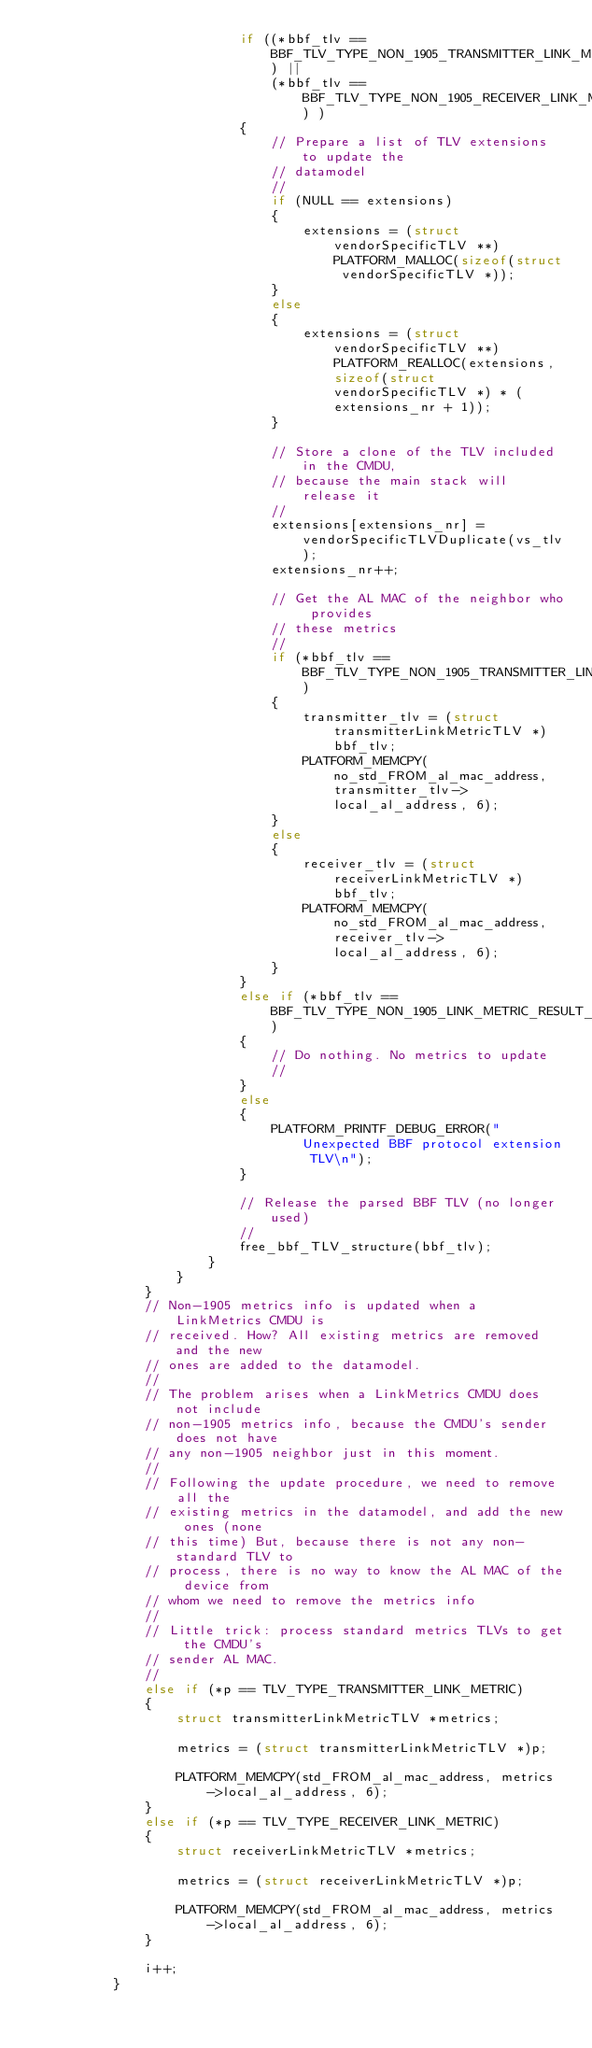<code> <loc_0><loc_0><loc_500><loc_500><_C_>                          if ((*bbf_tlv == BBF_TLV_TYPE_NON_1905_TRANSMITTER_LINK_METRIC) ||
                              (*bbf_tlv == BBF_TLV_TYPE_NON_1905_RECEIVER_LINK_METRIC) )
                          {
                              // Prepare a list of TLV extensions to update the
                              // datamodel
                              //
                              if (NULL == extensions)
                              {
                                  extensions = (struct vendorSpecificTLV **)PLATFORM_MALLOC(sizeof(struct vendorSpecificTLV *));
                              }
                              else
                              {
                                  extensions = (struct vendorSpecificTLV **)PLATFORM_REALLOC(extensions, sizeof(struct vendorSpecificTLV *) * (extensions_nr + 1));
                              }

                              // Store a clone of the TLV included in the CMDU,
                              // because the main stack will release it
                              //
                              extensions[extensions_nr] = vendorSpecificTLVDuplicate(vs_tlv);
                              extensions_nr++;

                              // Get the AL MAC of the neighbor who provides
                              // these metrics
                              //
                              if (*bbf_tlv == BBF_TLV_TYPE_NON_1905_TRANSMITTER_LINK_METRIC)
                              {
                                  transmitter_tlv = (struct transmitterLinkMetricTLV *)bbf_tlv;
                                  PLATFORM_MEMCPY(no_std_FROM_al_mac_address, transmitter_tlv->local_al_address, 6);
                              }
                              else
                              {
                                  receiver_tlv = (struct receiverLinkMetricTLV *)bbf_tlv;
                                  PLATFORM_MEMCPY(no_std_FROM_al_mac_address, receiver_tlv->local_al_address, 6);
                              }
                          }
                          else if (*bbf_tlv == BBF_TLV_TYPE_NON_1905_LINK_METRIC_RESULT_CODE)
                          {
                              // Do nothing. No metrics to update
                              //
                          }
                          else
                          {
                              PLATFORM_PRINTF_DEBUG_ERROR("Unexpected BBF protocol extension TLV\n");
                          }

                          // Release the parsed BBF TLV (no longer used)
                          //
                          free_bbf_TLV_structure(bbf_tlv);
                      }
                  }
              }
              // Non-1905 metrics info is updated when a LinkMetrics CMDU is
              // received. How? All existing metrics are removed and the new
              // ones are added to the datamodel.
              //
              // The problem arises when a LinkMetrics CMDU does not include
              // non-1905 metrics info, because the CMDU's sender does not have
              // any non-1905 neighbor just in this moment.
              //
              // Following the update procedure, we need to remove all the
              // existing metrics in the datamodel, and add the new ones (none
              // this time) But, because there is not any non-standard TLV to
              // process, there is no way to know the AL MAC of the device from
              // whom we need to remove the metrics info
              //
              // Little trick: process standard metrics TLVs to get the CMDU's
              // sender AL MAC.
              //
              else if (*p == TLV_TYPE_TRANSMITTER_LINK_METRIC)
              {
                  struct transmitterLinkMetricTLV *metrics;

                  metrics = (struct transmitterLinkMetricTLV *)p;

                  PLATFORM_MEMCPY(std_FROM_al_mac_address, metrics->local_al_address, 6);
              }
              else if (*p == TLV_TYPE_RECEIVER_LINK_METRIC)
              {
                  struct receiverLinkMetricTLV *metrics;

                  metrics = (struct receiverLinkMetricTLV *)p;

                  PLATFORM_MEMCPY(std_FROM_al_mac_address, metrics->local_al_address, 6);
              }

              i++;
          }
</code> 